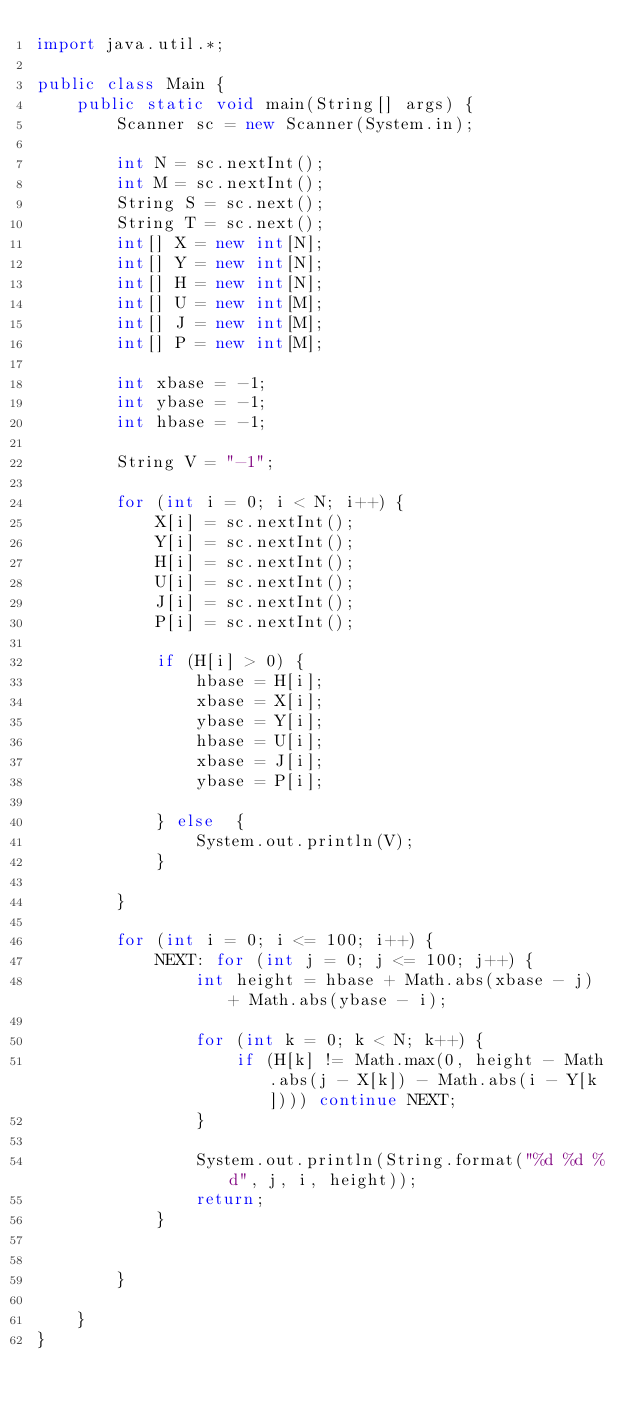<code> <loc_0><loc_0><loc_500><loc_500><_Java_>import java.util.*;

public class Main {
    public static void main(String[] args) {
        Scanner sc = new Scanner(System.in);

        int N = sc.nextInt();
        int M = sc.nextInt();
        String S = sc.next();
        String T = sc.next();
        int[] X = new int[N];
        int[] Y = new int[N];
        int[] H = new int[N];
        int[] U = new int[M];
        int[] J = new int[M];        
        int[] P = new int[M];
        
        int xbase = -1;
        int ybase = -1;
        int hbase = -1;

        String V = "-1";
        
        for (int i = 0; i < N; i++) {
            X[i] = sc.nextInt();
            Y[i] = sc.nextInt();
            H[i] = sc.nextInt();
            U[i] = sc.nextInt();
            J[i] = sc.nextInt();
            P[i] = sc.nextInt();

            if (H[i] > 0) {
                hbase = H[i];
                xbase = X[i];
                ybase = Y[i];
                hbase = U[i];
                xbase = J[i];
                ybase = P[i];
                
            } else  {
            	System.out.println(V);            	
            }
            
        }

        for (int i = 0; i <= 100; i++) {
            NEXT: for (int j = 0; j <= 100; j++) {
                int height = hbase + Math.abs(xbase - j) + Math.abs(ybase - i);

                for (int k = 0; k < N; k++) {
                    if (H[k] != Math.max(0, height - Math.abs(j - X[k]) - Math.abs(i - Y[k]))) continue NEXT;
                }

                System.out.println(String.format("%d %d %d", j, i, height));
                return;
            }
        

        }
        
    }
}</code> 